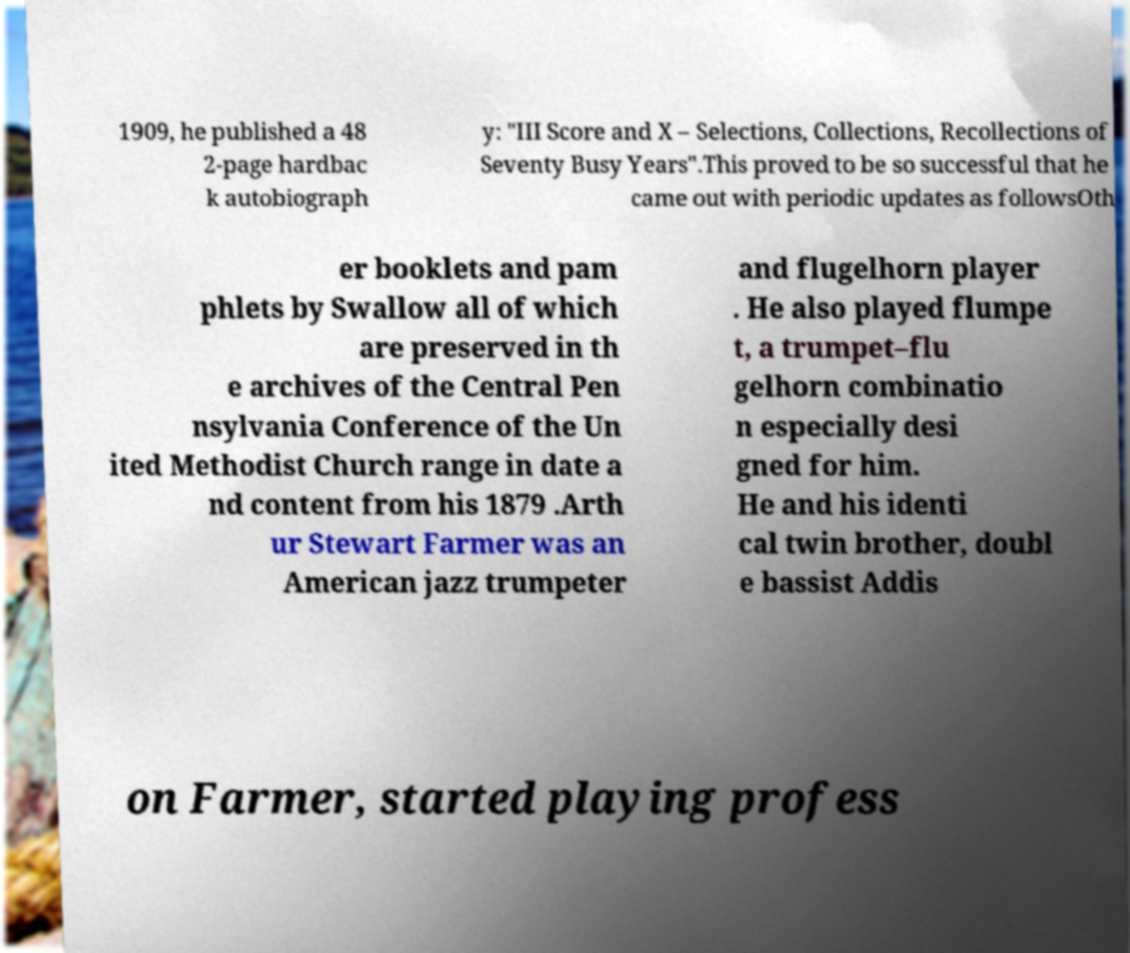Can you accurately transcribe the text from the provided image for me? 1909, he published a 48 2-page hardbac k autobiograph y: "III Score and X – Selections, Collections, Recollections of Seventy Busy Years".This proved to be so successful that he came out with periodic updates as followsOth er booklets and pam phlets by Swallow all of which are preserved in th e archives of the Central Pen nsylvania Conference of the Un ited Methodist Church range in date a nd content from his 1879 .Arth ur Stewart Farmer was an American jazz trumpeter and flugelhorn player . He also played flumpe t, a trumpet–flu gelhorn combinatio n especially desi gned for him. He and his identi cal twin brother, doubl e bassist Addis on Farmer, started playing profess 